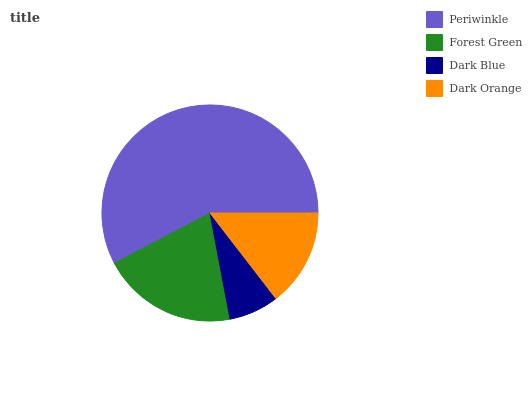Is Dark Blue the minimum?
Answer yes or no. Yes. Is Periwinkle the maximum?
Answer yes or no. Yes. Is Forest Green the minimum?
Answer yes or no. No. Is Forest Green the maximum?
Answer yes or no. No. Is Periwinkle greater than Forest Green?
Answer yes or no. Yes. Is Forest Green less than Periwinkle?
Answer yes or no. Yes. Is Forest Green greater than Periwinkle?
Answer yes or no. No. Is Periwinkle less than Forest Green?
Answer yes or no. No. Is Forest Green the high median?
Answer yes or no. Yes. Is Dark Orange the low median?
Answer yes or no. Yes. Is Periwinkle the high median?
Answer yes or no. No. Is Periwinkle the low median?
Answer yes or no. No. 